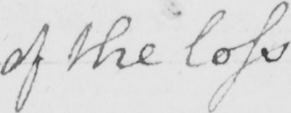Can you tell me what this handwritten text says? of the loss 